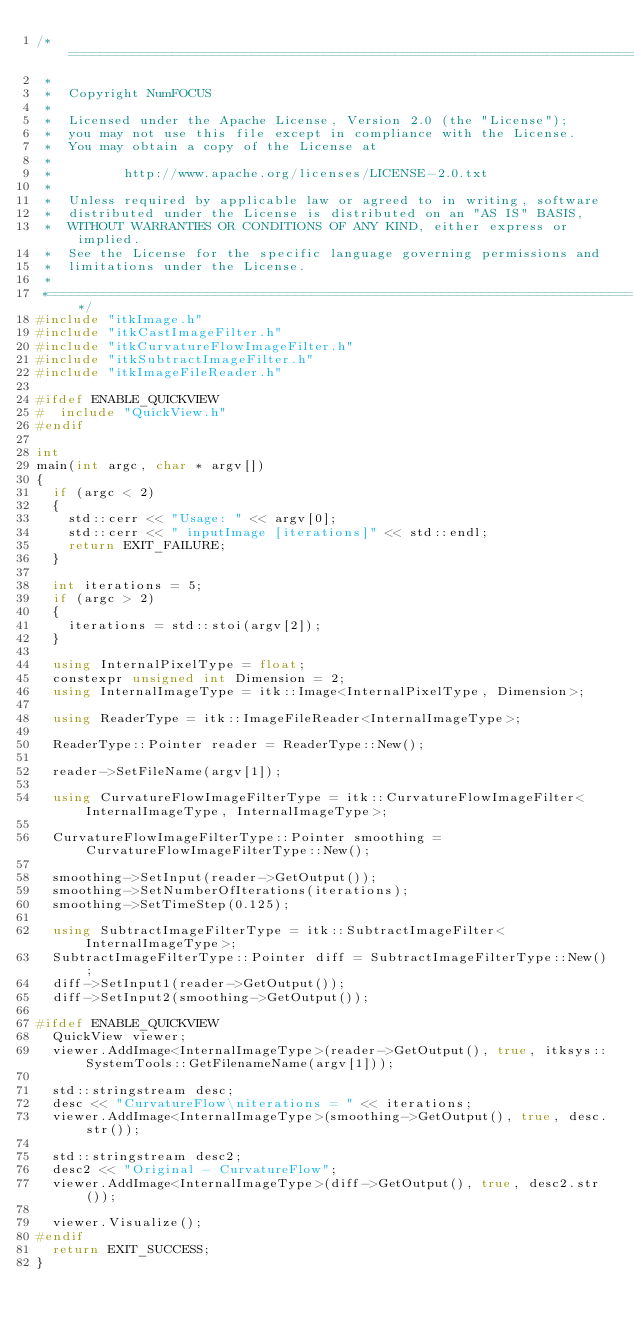<code> <loc_0><loc_0><loc_500><loc_500><_C++_>/*=========================================================================
 *
 *  Copyright NumFOCUS
 *
 *  Licensed under the Apache License, Version 2.0 (the "License");
 *  you may not use this file except in compliance with the License.
 *  You may obtain a copy of the License at
 *
 *         http://www.apache.org/licenses/LICENSE-2.0.txt
 *
 *  Unless required by applicable law or agreed to in writing, software
 *  distributed under the License is distributed on an "AS IS" BASIS,
 *  WITHOUT WARRANTIES OR CONDITIONS OF ANY KIND, either express or implied.
 *  See the License for the specific language governing permissions and
 *  limitations under the License.
 *
 *=========================================================================*/
#include "itkImage.h"
#include "itkCastImageFilter.h"
#include "itkCurvatureFlowImageFilter.h"
#include "itkSubtractImageFilter.h"
#include "itkImageFileReader.h"

#ifdef ENABLE_QUICKVIEW
#  include "QuickView.h"
#endif

int
main(int argc, char * argv[])
{
  if (argc < 2)
  {
    std::cerr << "Usage: " << argv[0];
    std::cerr << " inputImage [iterations]" << std::endl;
    return EXIT_FAILURE;
  }

  int iterations = 5;
  if (argc > 2)
  {
    iterations = std::stoi(argv[2]);
  }

  using InternalPixelType = float;
  constexpr unsigned int Dimension = 2;
  using InternalImageType = itk::Image<InternalPixelType, Dimension>;

  using ReaderType = itk::ImageFileReader<InternalImageType>;

  ReaderType::Pointer reader = ReaderType::New();

  reader->SetFileName(argv[1]);

  using CurvatureFlowImageFilterType = itk::CurvatureFlowImageFilter<InternalImageType, InternalImageType>;

  CurvatureFlowImageFilterType::Pointer smoothing = CurvatureFlowImageFilterType::New();

  smoothing->SetInput(reader->GetOutput());
  smoothing->SetNumberOfIterations(iterations);
  smoothing->SetTimeStep(0.125);

  using SubtractImageFilterType = itk::SubtractImageFilter<InternalImageType>;
  SubtractImageFilterType::Pointer diff = SubtractImageFilterType::New();
  diff->SetInput1(reader->GetOutput());
  diff->SetInput2(smoothing->GetOutput());

#ifdef ENABLE_QUICKVIEW
  QuickView viewer;
  viewer.AddImage<InternalImageType>(reader->GetOutput(), true, itksys::SystemTools::GetFilenameName(argv[1]));

  std::stringstream desc;
  desc << "CurvatureFlow\niterations = " << iterations;
  viewer.AddImage<InternalImageType>(smoothing->GetOutput(), true, desc.str());

  std::stringstream desc2;
  desc2 << "Original - CurvatureFlow";
  viewer.AddImage<InternalImageType>(diff->GetOutput(), true, desc2.str());

  viewer.Visualize();
#endif
  return EXIT_SUCCESS;
}
</code> 